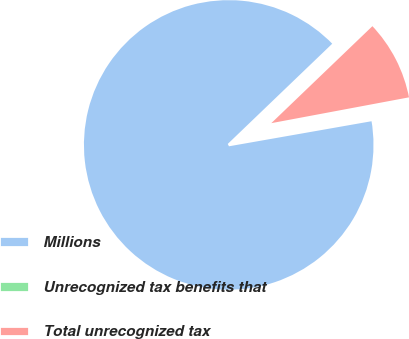Convert chart to OTSL. <chart><loc_0><loc_0><loc_500><loc_500><pie_chart><fcel>Millions<fcel>Unrecognized tax benefits that<fcel>Total unrecognized tax<nl><fcel>90.6%<fcel>0.18%<fcel>9.22%<nl></chart> 